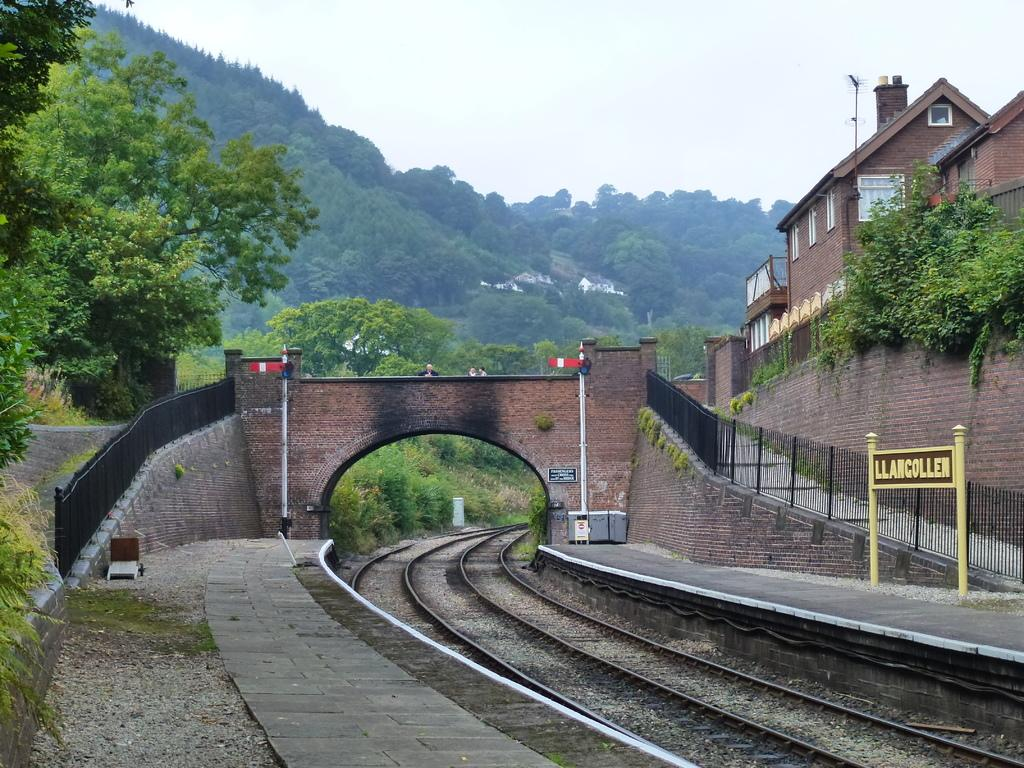<image>
Describe the image concisely. A railroad with a gate that says Llancollen 